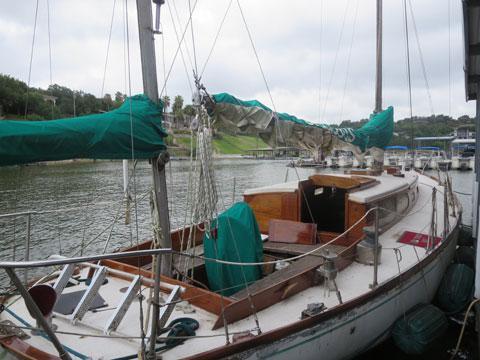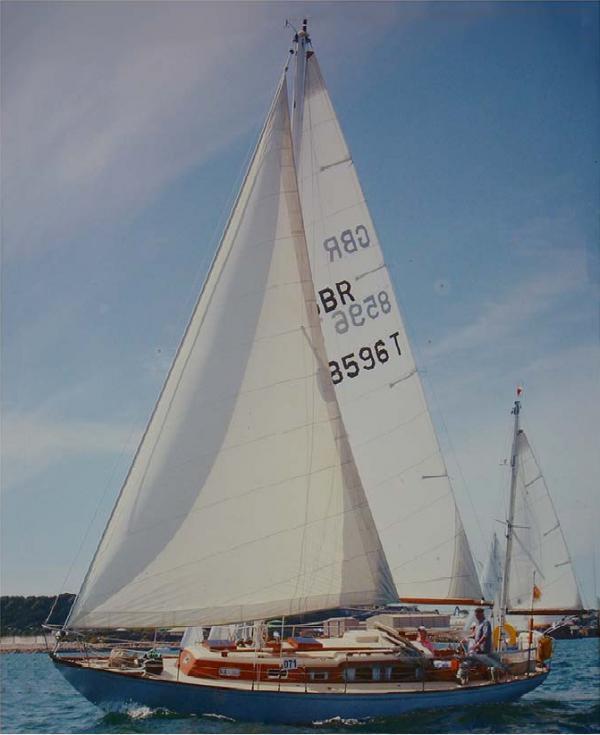The first image is the image on the left, the second image is the image on the right. Analyze the images presented: Is the assertion "At least one sailboat has white sails unfurled." valid? Answer yes or no. Yes. The first image is the image on the left, the second image is the image on the right. For the images shown, is this caption "there are white inflated sails in the image on the right" true? Answer yes or no. Yes. 